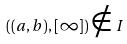Convert formula to latex. <formula><loc_0><loc_0><loc_500><loc_500>( ( a , b ) , [ \infty ] ) \notin I</formula> 